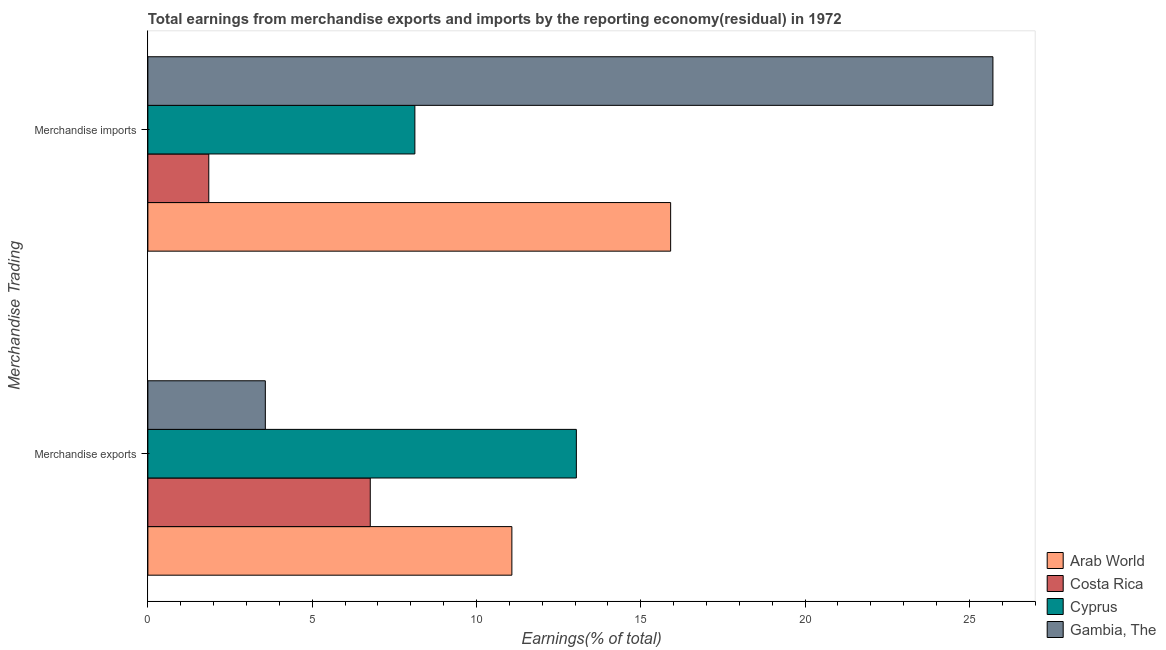What is the earnings from merchandise imports in Gambia, The?
Give a very brief answer. 25.72. Across all countries, what is the maximum earnings from merchandise imports?
Provide a succinct answer. 25.72. Across all countries, what is the minimum earnings from merchandise exports?
Offer a very short reply. 3.57. In which country was the earnings from merchandise exports maximum?
Your answer should be very brief. Cyprus. In which country was the earnings from merchandise imports minimum?
Make the answer very short. Costa Rica. What is the total earnings from merchandise exports in the graph?
Your response must be concise. 34.46. What is the difference between the earnings from merchandise imports in Cyprus and that in Costa Rica?
Keep it short and to the point. 6.27. What is the difference between the earnings from merchandise imports in Cyprus and the earnings from merchandise exports in Gambia, The?
Provide a short and direct response. 4.55. What is the average earnings from merchandise imports per country?
Give a very brief answer. 12.9. What is the difference between the earnings from merchandise imports and earnings from merchandise exports in Gambia, The?
Give a very brief answer. 22.14. In how many countries, is the earnings from merchandise imports greater than 4 %?
Provide a succinct answer. 3. What is the ratio of the earnings from merchandise exports in Costa Rica to that in Arab World?
Ensure brevity in your answer.  0.61. Is the earnings from merchandise imports in Cyprus less than that in Costa Rica?
Offer a very short reply. No. In how many countries, is the earnings from merchandise imports greater than the average earnings from merchandise imports taken over all countries?
Keep it short and to the point. 2. What does the 4th bar from the top in Merchandise exports represents?
Your answer should be compact. Arab World. What does the 1st bar from the bottom in Merchandise imports represents?
Keep it short and to the point. Arab World. How many bars are there?
Offer a terse response. 8. Does the graph contain any zero values?
Ensure brevity in your answer.  No. Does the graph contain grids?
Ensure brevity in your answer.  No. How many legend labels are there?
Make the answer very short. 4. What is the title of the graph?
Offer a terse response. Total earnings from merchandise exports and imports by the reporting economy(residual) in 1972. Does "Malta" appear as one of the legend labels in the graph?
Offer a terse response. No. What is the label or title of the X-axis?
Your response must be concise. Earnings(% of total). What is the label or title of the Y-axis?
Keep it short and to the point. Merchandise Trading. What is the Earnings(% of total) in Arab World in Merchandise exports?
Your answer should be compact. 11.08. What is the Earnings(% of total) of Costa Rica in Merchandise exports?
Provide a short and direct response. 6.77. What is the Earnings(% of total) of Cyprus in Merchandise exports?
Provide a short and direct response. 13.04. What is the Earnings(% of total) of Gambia, The in Merchandise exports?
Offer a very short reply. 3.57. What is the Earnings(% of total) in Arab World in Merchandise imports?
Make the answer very short. 15.91. What is the Earnings(% of total) in Costa Rica in Merchandise imports?
Keep it short and to the point. 1.85. What is the Earnings(% of total) in Cyprus in Merchandise imports?
Offer a very short reply. 8.13. What is the Earnings(% of total) of Gambia, The in Merchandise imports?
Ensure brevity in your answer.  25.72. Across all Merchandise Trading, what is the maximum Earnings(% of total) in Arab World?
Give a very brief answer. 15.91. Across all Merchandise Trading, what is the maximum Earnings(% of total) of Costa Rica?
Offer a terse response. 6.77. Across all Merchandise Trading, what is the maximum Earnings(% of total) in Cyprus?
Provide a short and direct response. 13.04. Across all Merchandise Trading, what is the maximum Earnings(% of total) in Gambia, The?
Make the answer very short. 25.72. Across all Merchandise Trading, what is the minimum Earnings(% of total) in Arab World?
Ensure brevity in your answer.  11.08. Across all Merchandise Trading, what is the minimum Earnings(% of total) in Costa Rica?
Offer a very short reply. 1.85. Across all Merchandise Trading, what is the minimum Earnings(% of total) in Cyprus?
Ensure brevity in your answer.  8.13. Across all Merchandise Trading, what is the minimum Earnings(% of total) of Gambia, The?
Keep it short and to the point. 3.57. What is the total Earnings(% of total) of Arab World in the graph?
Provide a succinct answer. 26.99. What is the total Earnings(% of total) of Costa Rica in the graph?
Ensure brevity in your answer.  8.62. What is the total Earnings(% of total) in Cyprus in the graph?
Your response must be concise. 21.17. What is the total Earnings(% of total) in Gambia, The in the graph?
Offer a very short reply. 29.29. What is the difference between the Earnings(% of total) in Arab World in Merchandise exports and that in Merchandise imports?
Offer a terse response. -4.83. What is the difference between the Earnings(% of total) of Costa Rica in Merchandise exports and that in Merchandise imports?
Your response must be concise. 4.91. What is the difference between the Earnings(% of total) of Cyprus in Merchandise exports and that in Merchandise imports?
Keep it short and to the point. 4.91. What is the difference between the Earnings(% of total) in Gambia, The in Merchandise exports and that in Merchandise imports?
Your answer should be very brief. -22.14. What is the difference between the Earnings(% of total) in Arab World in Merchandise exports and the Earnings(% of total) in Costa Rica in Merchandise imports?
Your answer should be very brief. 9.22. What is the difference between the Earnings(% of total) of Arab World in Merchandise exports and the Earnings(% of total) of Cyprus in Merchandise imports?
Offer a terse response. 2.95. What is the difference between the Earnings(% of total) in Arab World in Merchandise exports and the Earnings(% of total) in Gambia, The in Merchandise imports?
Your response must be concise. -14.64. What is the difference between the Earnings(% of total) in Costa Rica in Merchandise exports and the Earnings(% of total) in Cyprus in Merchandise imports?
Your response must be concise. -1.36. What is the difference between the Earnings(% of total) in Costa Rica in Merchandise exports and the Earnings(% of total) in Gambia, The in Merchandise imports?
Make the answer very short. -18.95. What is the difference between the Earnings(% of total) of Cyprus in Merchandise exports and the Earnings(% of total) of Gambia, The in Merchandise imports?
Offer a terse response. -12.68. What is the average Earnings(% of total) in Arab World per Merchandise Trading?
Offer a very short reply. 13.49. What is the average Earnings(% of total) of Costa Rica per Merchandise Trading?
Keep it short and to the point. 4.31. What is the average Earnings(% of total) in Cyprus per Merchandise Trading?
Your answer should be compact. 10.58. What is the average Earnings(% of total) in Gambia, The per Merchandise Trading?
Offer a very short reply. 14.65. What is the difference between the Earnings(% of total) of Arab World and Earnings(% of total) of Costa Rica in Merchandise exports?
Your response must be concise. 4.31. What is the difference between the Earnings(% of total) in Arab World and Earnings(% of total) in Cyprus in Merchandise exports?
Your answer should be compact. -1.96. What is the difference between the Earnings(% of total) of Arab World and Earnings(% of total) of Gambia, The in Merchandise exports?
Your answer should be compact. 7.5. What is the difference between the Earnings(% of total) in Costa Rica and Earnings(% of total) in Cyprus in Merchandise exports?
Give a very brief answer. -6.27. What is the difference between the Earnings(% of total) in Costa Rica and Earnings(% of total) in Gambia, The in Merchandise exports?
Give a very brief answer. 3.19. What is the difference between the Earnings(% of total) in Cyprus and Earnings(% of total) in Gambia, The in Merchandise exports?
Give a very brief answer. 9.47. What is the difference between the Earnings(% of total) in Arab World and Earnings(% of total) in Costa Rica in Merchandise imports?
Offer a very short reply. 14.06. What is the difference between the Earnings(% of total) of Arab World and Earnings(% of total) of Cyprus in Merchandise imports?
Keep it short and to the point. 7.78. What is the difference between the Earnings(% of total) of Arab World and Earnings(% of total) of Gambia, The in Merchandise imports?
Offer a very short reply. -9.81. What is the difference between the Earnings(% of total) in Costa Rica and Earnings(% of total) in Cyprus in Merchandise imports?
Give a very brief answer. -6.27. What is the difference between the Earnings(% of total) of Costa Rica and Earnings(% of total) of Gambia, The in Merchandise imports?
Provide a short and direct response. -23.87. What is the difference between the Earnings(% of total) in Cyprus and Earnings(% of total) in Gambia, The in Merchandise imports?
Make the answer very short. -17.59. What is the ratio of the Earnings(% of total) in Arab World in Merchandise exports to that in Merchandise imports?
Provide a succinct answer. 0.7. What is the ratio of the Earnings(% of total) in Costa Rica in Merchandise exports to that in Merchandise imports?
Your response must be concise. 3.65. What is the ratio of the Earnings(% of total) in Cyprus in Merchandise exports to that in Merchandise imports?
Offer a very short reply. 1.6. What is the ratio of the Earnings(% of total) in Gambia, The in Merchandise exports to that in Merchandise imports?
Make the answer very short. 0.14. What is the difference between the highest and the second highest Earnings(% of total) in Arab World?
Provide a short and direct response. 4.83. What is the difference between the highest and the second highest Earnings(% of total) in Costa Rica?
Provide a short and direct response. 4.91. What is the difference between the highest and the second highest Earnings(% of total) in Cyprus?
Offer a very short reply. 4.91. What is the difference between the highest and the second highest Earnings(% of total) of Gambia, The?
Your answer should be compact. 22.14. What is the difference between the highest and the lowest Earnings(% of total) of Arab World?
Provide a succinct answer. 4.83. What is the difference between the highest and the lowest Earnings(% of total) of Costa Rica?
Offer a terse response. 4.91. What is the difference between the highest and the lowest Earnings(% of total) in Cyprus?
Your response must be concise. 4.91. What is the difference between the highest and the lowest Earnings(% of total) of Gambia, The?
Offer a very short reply. 22.14. 